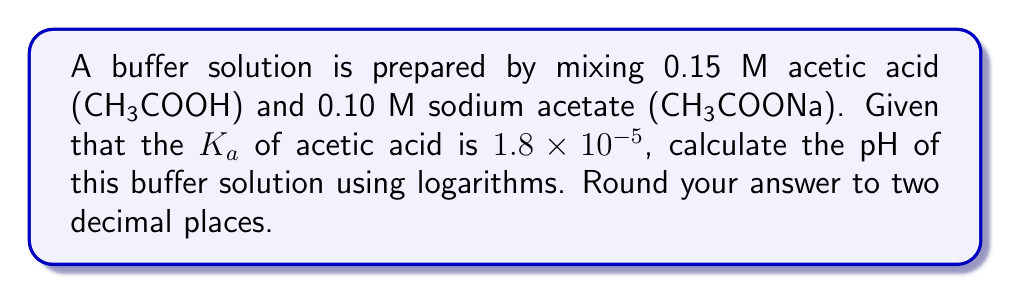Show me your answer to this math problem. Let's approach this step-by-step:

1) First, recall the Henderson-Hasselbalch equation for pH:

   $$ pH = pK_a + \log\left(\frac{[A^-]}{[HA]}\right) $$

   Where $[A^-]$ is the concentration of the conjugate base and $[HA]$ is the concentration of the weak acid.

2) We need to calculate $pK_a$:
   
   $$ pK_a = -\log(K_a) = -\log(1.8 \times 10^{-5}) = 4.74 $$

3) In this buffer, $[HA]$ is the concentration of acetic acid (0.15 M) and $[A^-]$ is the concentration of acetate ion from sodium acetate (0.10 M).

4) Now, let's substitute these values into the Henderson-Hasselbalch equation:

   $$ pH = 4.74 + \log\left(\frac{0.10}{0.15}\right) $$

5) Simplify inside the logarithm:

   $$ pH = 4.74 + \log(0.667) $$

6) Calculate the logarithm:

   $$ pH = 4.74 + (-0.176) = 4.564 $$

7) Rounding to two decimal places:

   $$ pH = 4.56 $$
Answer: $4.56$ 